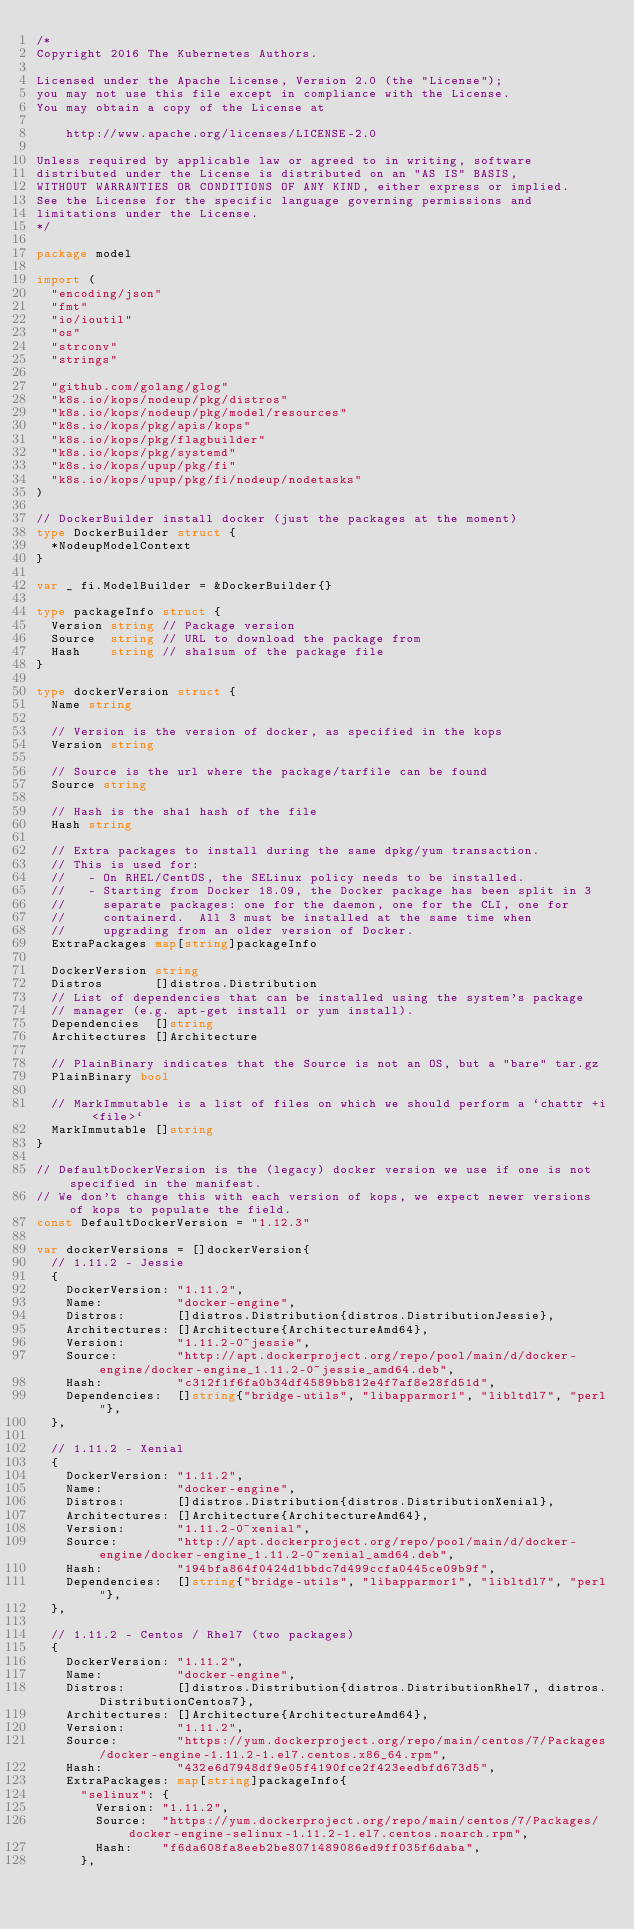Convert code to text. <code><loc_0><loc_0><loc_500><loc_500><_Go_>/*
Copyright 2016 The Kubernetes Authors.

Licensed under the Apache License, Version 2.0 (the "License");
you may not use this file except in compliance with the License.
You may obtain a copy of the License at

    http://www.apache.org/licenses/LICENSE-2.0

Unless required by applicable law or agreed to in writing, software
distributed under the License is distributed on an "AS IS" BASIS,
WITHOUT WARRANTIES OR CONDITIONS OF ANY KIND, either express or implied.
See the License for the specific language governing permissions and
limitations under the License.
*/

package model

import (
	"encoding/json"
	"fmt"
	"io/ioutil"
	"os"
	"strconv"
	"strings"

	"github.com/golang/glog"
	"k8s.io/kops/nodeup/pkg/distros"
	"k8s.io/kops/nodeup/pkg/model/resources"
	"k8s.io/kops/pkg/apis/kops"
	"k8s.io/kops/pkg/flagbuilder"
	"k8s.io/kops/pkg/systemd"
	"k8s.io/kops/upup/pkg/fi"
	"k8s.io/kops/upup/pkg/fi/nodeup/nodetasks"
)

// DockerBuilder install docker (just the packages at the moment)
type DockerBuilder struct {
	*NodeupModelContext
}

var _ fi.ModelBuilder = &DockerBuilder{}

type packageInfo struct {
	Version string // Package version
	Source  string // URL to download the package from
	Hash    string // sha1sum of the package file
}

type dockerVersion struct {
	Name string

	// Version is the version of docker, as specified in the kops
	Version string

	// Source is the url where the package/tarfile can be found
	Source string

	// Hash is the sha1 hash of the file
	Hash string

	// Extra packages to install during the same dpkg/yum transaction.
	// This is used for:
	//   - On RHEL/CentOS, the SELinux policy needs to be installed.
	//   - Starting from Docker 18.09, the Docker package has been split in 3
	//     separate packages: one for the daemon, one for the CLI, one for
	//     containerd.  All 3 must be installed at the same time when
	//     upgrading from an older version of Docker.
	ExtraPackages map[string]packageInfo

	DockerVersion string
	Distros       []distros.Distribution
	// List of dependencies that can be installed using the system's package
	// manager (e.g. apt-get install or yum install).
	Dependencies  []string
	Architectures []Architecture

	// PlainBinary indicates that the Source is not an OS, but a "bare" tar.gz
	PlainBinary bool

	// MarkImmutable is a list of files on which we should perform a `chattr +i <file>`
	MarkImmutable []string
}

// DefaultDockerVersion is the (legacy) docker version we use if one is not specified in the manifest.
// We don't change this with each version of kops, we expect newer versions of kops to populate the field.
const DefaultDockerVersion = "1.12.3"

var dockerVersions = []dockerVersion{
	// 1.11.2 - Jessie
	{
		DockerVersion: "1.11.2",
		Name:          "docker-engine",
		Distros:       []distros.Distribution{distros.DistributionJessie},
		Architectures: []Architecture{ArchitectureAmd64},
		Version:       "1.11.2-0~jessie",
		Source:        "http://apt.dockerproject.org/repo/pool/main/d/docker-engine/docker-engine_1.11.2-0~jessie_amd64.deb",
		Hash:          "c312f1f6fa0b34df4589bb812e4f7af8e28fd51d",
		Dependencies:  []string{"bridge-utils", "libapparmor1", "libltdl7", "perl"},
	},

	// 1.11.2 - Xenial
	{
		DockerVersion: "1.11.2",
		Name:          "docker-engine",
		Distros:       []distros.Distribution{distros.DistributionXenial},
		Architectures: []Architecture{ArchitectureAmd64},
		Version:       "1.11.2-0~xenial",
		Source:        "http://apt.dockerproject.org/repo/pool/main/d/docker-engine/docker-engine_1.11.2-0~xenial_amd64.deb",
		Hash:          "194bfa864f0424d1bbdc7d499ccfa0445ce09b9f",
		Dependencies:  []string{"bridge-utils", "libapparmor1", "libltdl7", "perl"},
	},

	// 1.11.2 - Centos / Rhel7 (two packages)
	{
		DockerVersion: "1.11.2",
		Name:          "docker-engine",
		Distros:       []distros.Distribution{distros.DistributionRhel7, distros.DistributionCentos7},
		Architectures: []Architecture{ArchitectureAmd64},
		Version:       "1.11.2",
		Source:        "https://yum.dockerproject.org/repo/main/centos/7/Packages/docker-engine-1.11.2-1.el7.centos.x86_64.rpm",
		Hash:          "432e6d7948df9e05f4190fce2f423eedbfd673d5",
		ExtraPackages: map[string]packageInfo{
			"selinux": {
				Version: "1.11.2",
				Source:  "https://yum.dockerproject.org/repo/main/centos/7/Packages/docker-engine-selinux-1.11.2-1.el7.centos.noarch.rpm",
				Hash:    "f6da608fa8eeb2be8071489086ed9ff035f6daba",
			},</code> 